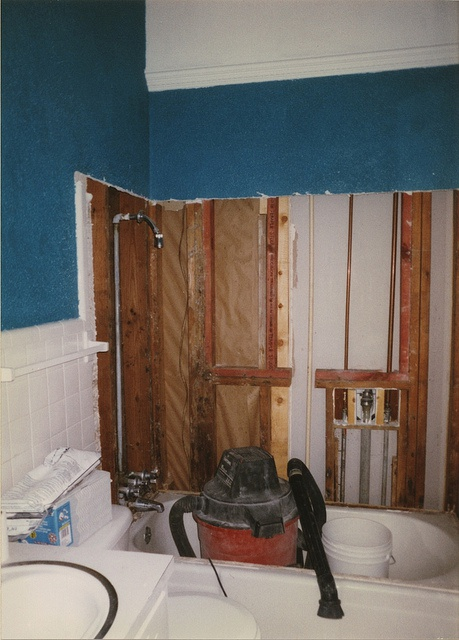Describe the objects in this image and their specific colors. I can see sink in gray, lightgray, and black tones, toilet in gray, darkgray, and lightgray tones, and toilet in gray and darkgray tones in this image. 